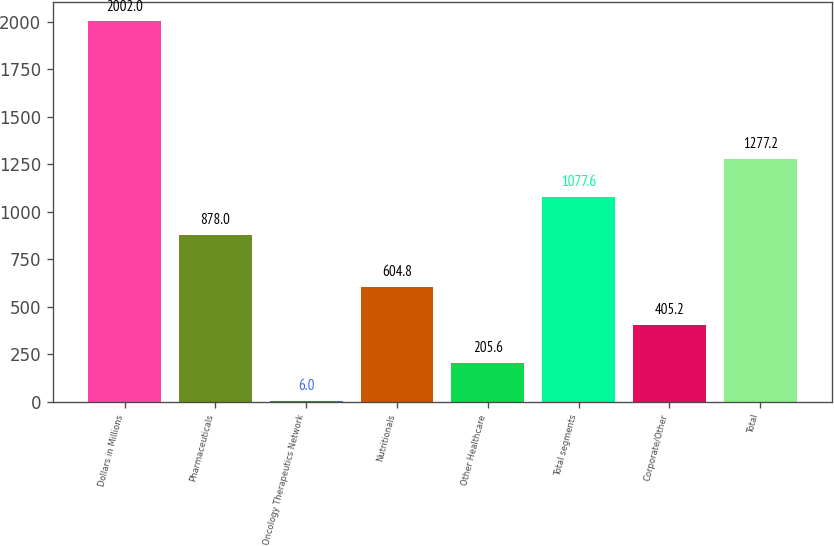<chart> <loc_0><loc_0><loc_500><loc_500><bar_chart><fcel>Dollars in Millions<fcel>Pharmaceuticals<fcel>Oncology Therapeutics Network<fcel>Nutritionals<fcel>Other Healthcare<fcel>Total segments<fcel>Corporate/Other<fcel>Total<nl><fcel>2002<fcel>878<fcel>6<fcel>604.8<fcel>205.6<fcel>1077.6<fcel>405.2<fcel>1277.2<nl></chart> 